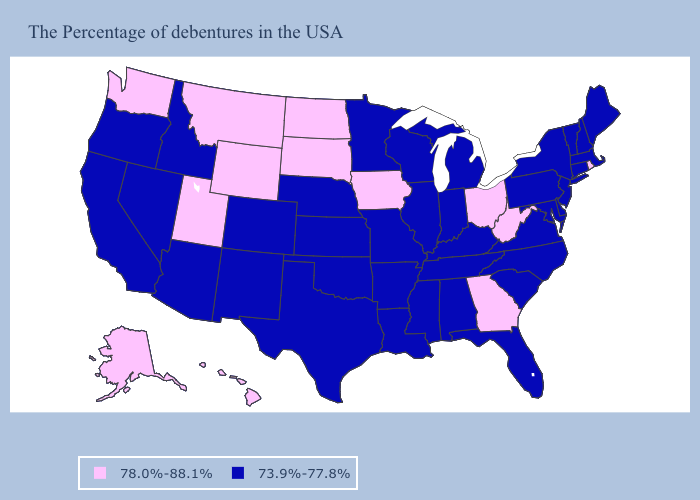Among the states that border Tennessee , which have the highest value?
Answer briefly. Georgia. Does New Hampshire have a higher value than Tennessee?
Be succinct. No. Does the first symbol in the legend represent the smallest category?
Quick response, please. No. What is the highest value in the USA?
Answer briefly. 78.0%-88.1%. What is the highest value in the USA?
Keep it brief. 78.0%-88.1%. Name the states that have a value in the range 78.0%-88.1%?
Be succinct. Rhode Island, West Virginia, Ohio, Georgia, Iowa, South Dakota, North Dakota, Wyoming, Utah, Montana, Washington, Alaska, Hawaii. Is the legend a continuous bar?
Give a very brief answer. No. Which states have the lowest value in the Northeast?
Answer briefly. Maine, Massachusetts, New Hampshire, Vermont, Connecticut, New York, New Jersey, Pennsylvania. What is the lowest value in states that border Georgia?
Concise answer only. 73.9%-77.8%. Which states have the highest value in the USA?
Short answer required. Rhode Island, West Virginia, Ohio, Georgia, Iowa, South Dakota, North Dakota, Wyoming, Utah, Montana, Washington, Alaska, Hawaii. What is the highest value in states that border Florida?
Concise answer only. 78.0%-88.1%. Does Utah have the highest value in the West?
Answer briefly. Yes. What is the value of Oklahoma?
Answer briefly. 73.9%-77.8%. What is the value of New Hampshire?
Keep it brief. 73.9%-77.8%. What is the value of Maryland?
Give a very brief answer. 73.9%-77.8%. 